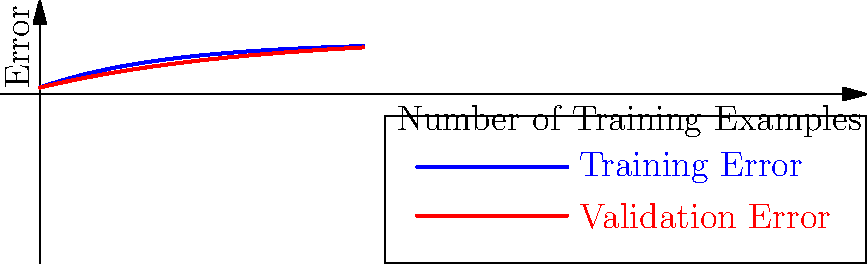Given the learning curve shown above, which represents the training and validation errors for a machine learning model as the number of training examples increases, what can you conclude about the model's performance? Is it overfitting, underfitting, or well-fitted? To analyze the learning curve and determine if the model is overfitting, underfitting, or well-fitted, we need to consider the following steps:

1. Observe the training error (blue line):
   - It starts high and decreases as the number of training examples increases.
   - This is expected behavior, as the model learns from more data.

2. Observe the validation error (red line):
   - It also starts high and decreases as the number of training examples increases.
   - This indicates that the model is generalizing well to unseen data.

3. Compare the training and validation errors:
   - Both errors converge to similar values as the number of training examples increases.
   - The gap between training and validation errors is relatively small.

4. Assess for overfitting:
   - Overfitting would be indicated by a low training error and a high validation error.
   - In this case, we don't see a significant gap between training and validation errors.

5. Assess for underfitting:
   - Underfitting would be indicated by high errors for both training and validation sets.
   - In this case, both errors converge to relatively low values.

6. Conclusion:
   - The model appears to be well-fitted because:
     a) Both training and validation errors decrease and converge.
     b) There is no significant gap between training and validation errors.
     c) The final error values are relatively low.

This learning curve suggests that the model is learning effectively from the data and generalizing well to unseen examples, indicating a well-fitted model.
Answer: Well-fitted 